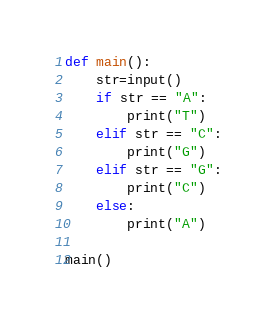Convert code to text. <code><loc_0><loc_0><loc_500><loc_500><_Python_>def main():
    str=input()
    if str == "A":
        print("T")
    elif str == "C":
        print("G")
    elif str == "G":
        print("C")
    else:
        print("A")

main()</code> 